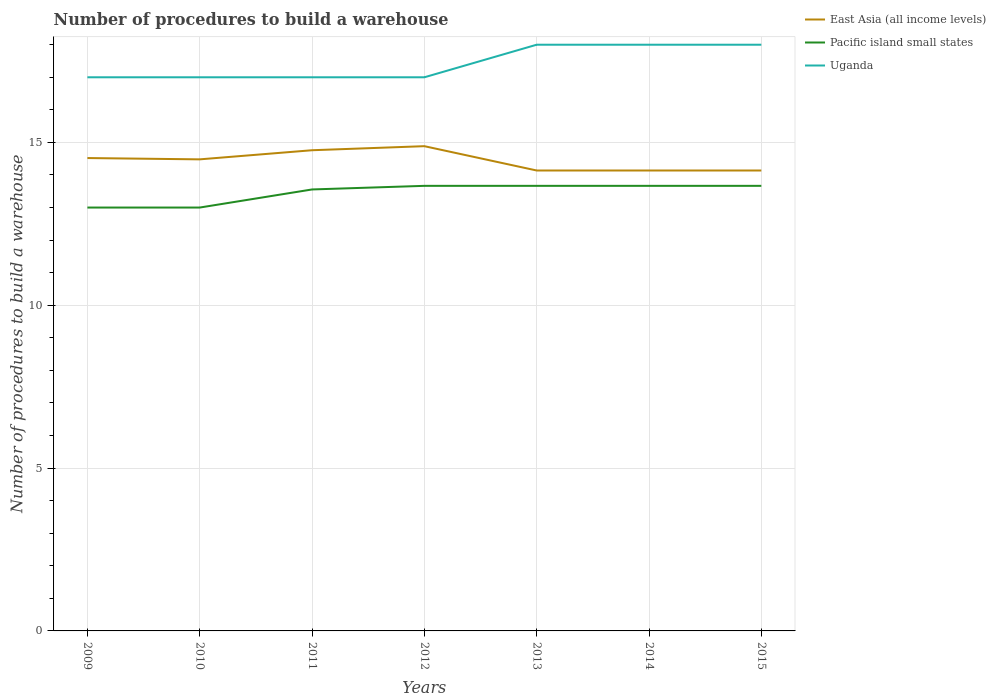How many different coloured lines are there?
Offer a very short reply. 3. Is the number of lines equal to the number of legend labels?
Offer a terse response. Yes. Across all years, what is the maximum number of procedures to build a warehouse in in East Asia (all income levels)?
Provide a short and direct response. 14.14. In which year was the number of procedures to build a warehouse in in Uganda maximum?
Keep it short and to the point. 2009. What is the total number of procedures to build a warehouse in in Pacific island small states in the graph?
Provide a short and direct response. 0. What is the difference between the highest and the second highest number of procedures to build a warehouse in in Uganda?
Provide a succinct answer. 1. How many lines are there?
Offer a very short reply. 3. How many years are there in the graph?
Make the answer very short. 7. What is the difference between two consecutive major ticks on the Y-axis?
Ensure brevity in your answer.  5. Does the graph contain any zero values?
Ensure brevity in your answer.  No. How many legend labels are there?
Give a very brief answer. 3. What is the title of the graph?
Offer a terse response. Number of procedures to build a warehouse. Does "Latin America(developing only)" appear as one of the legend labels in the graph?
Offer a terse response. No. What is the label or title of the X-axis?
Your response must be concise. Years. What is the label or title of the Y-axis?
Your answer should be very brief. Number of procedures to build a warehouse. What is the Number of procedures to build a warehouse in East Asia (all income levels) in 2009?
Your answer should be very brief. 14.52. What is the Number of procedures to build a warehouse of Pacific island small states in 2009?
Give a very brief answer. 13. What is the Number of procedures to build a warehouse of East Asia (all income levels) in 2010?
Give a very brief answer. 14.48. What is the Number of procedures to build a warehouse in East Asia (all income levels) in 2011?
Provide a short and direct response. 14.76. What is the Number of procedures to build a warehouse in Pacific island small states in 2011?
Keep it short and to the point. 13.56. What is the Number of procedures to build a warehouse of Uganda in 2011?
Your answer should be compact. 17. What is the Number of procedures to build a warehouse in East Asia (all income levels) in 2012?
Give a very brief answer. 14.88. What is the Number of procedures to build a warehouse of Pacific island small states in 2012?
Your response must be concise. 13.67. What is the Number of procedures to build a warehouse in Uganda in 2012?
Provide a succinct answer. 17. What is the Number of procedures to build a warehouse of East Asia (all income levels) in 2013?
Ensure brevity in your answer.  14.14. What is the Number of procedures to build a warehouse in Pacific island small states in 2013?
Keep it short and to the point. 13.67. What is the Number of procedures to build a warehouse of Uganda in 2013?
Provide a short and direct response. 18. What is the Number of procedures to build a warehouse in East Asia (all income levels) in 2014?
Your answer should be very brief. 14.14. What is the Number of procedures to build a warehouse in Pacific island small states in 2014?
Offer a terse response. 13.67. What is the Number of procedures to build a warehouse of East Asia (all income levels) in 2015?
Make the answer very short. 14.14. What is the Number of procedures to build a warehouse in Pacific island small states in 2015?
Provide a succinct answer. 13.67. What is the Number of procedures to build a warehouse of Uganda in 2015?
Offer a terse response. 18. Across all years, what is the maximum Number of procedures to build a warehouse of East Asia (all income levels)?
Your answer should be very brief. 14.88. Across all years, what is the maximum Number of procedures to build a warehouse of Pacific island small states?
Your answer should be very brief. 13.67. Across all years, what is the maximum Number of procedures to build a warehouse in Uganda?
Your response must be concise. 18. Across all years, what is the minimum Number of procedures to build a warehouse in East Asia (all income levels)?
Keep it short and to the point. 14.14. What is the total Number of procedures to build a warehouse of East Asia (all income levels) in the graph?
Ensure brevity in your answer.  101.06. What is the total Number of procedures to build a warehouse of Pacific island small states in the graph?
Offer a very short reply. 94.22. What is the total Number of procedures to build a warehouse of Uganda in the graph?
Offer a very short reply. 122. What is the difference between the Number of procedures to build a warehouse of East Asia (all income levels) in 2009 and that in 2010?
Ensure brevity in your answer.  0.04. What is the difference between the Number of procedures to build a warehouse in Pacific island small states in 2009 and that in 2010?
Offer a terse response. 0. What is the difference between the Number of procedures to build a warehouse in East Asia (all income levels) in 2009 and that in 2011?
Ensure brevity in your answer.  -0.24. What is the difference between the Number of procedures to build a warehouse in Pacific island small states in 2009 and that in 2011?
Your answer should be compact. -0.56. What is the difference between the Number of procedures to build a warehouse in East Asia (all income levels) in 2009 and that in 2012?
Give a very brief answer. -0.36. What is the difference between the Number of procedures to build a warehouse of Pacific island small states in 2009 and that in 2012?
Give a very brief answer. -0.67. What is the difference between the Number of procedures to build a warehouse of Uganda in 2009 and that in 2012?
Offer a terse response. 0. What is the difference between the Number of procedures to build a warehouse of East Asia (all income levels) in 2009 and that in 2013?
Offer a very short reply. 0.38. What is the difference between the Number of procedures to build a warehouse in Uganda in 2009 and that in 2013?
Ensure brevity in your answer.  -1. What is the difference between the Number of procedures to build a warehouse of East Asia (all income levels) in 2009 and that in 2014?
Ensure brevity in your answer.  0.38. What is the difference between the Number of procedures to build a warehouse in Pacific island small states in 2009 and that in 2014?
Keep it short and to the point. -0.67. What is the difference between the Number of procedures to build a warehouse in Uganda in 2009 and that in 2014?
Provide a succinct answer. -1. What is the difference between the Number of procedures to build a warehouse of East Asia (all income levels) in 2009 and that in 2015?
Make the answer very short. 0.38. What is the difference between the Number of procedures to build a warehouse of Pacific island small states in 2009 and that in 2015?
Provide a succinct answer. -0.67. What is the difference between the Number of procedures to build a warehouse of East Asia (all income levels) in 2010 and that in 2011?
Your answer should be compact. -0.28. What is the difference between the Number of procedures to build a warehouse in Pacific island small states in 2010 and that in 2011?
Your answer should be compact. -0.56. What is the difference between the Number of procedures to build a warehouse in Uganda in 2010 and that in 2011?
Make the answer very short. 0. What is the difference between the Number of procedures to build a warehouse of East Asia (all income levels) in 2010 and that in 2012?
Your response must be concise. -0.4. What is the difference between the Number of procedures to build a warehouse in Uganda in 2010 and that in 2012?
Make the answer very short. 0. What is the difference between the Number of procedures to build a warehouse of East Asia (all income levels) in 2010 and that in 2013?
Ensure brevity in your answer.  0.34. What is the difference between the Number of procedures to build a warehouse of Pacific island small states in 2010 and that in 2013?
Ensure brevity in your answer.  -0.67. What is the difference between the Number of procedures to build a warehouse of Uganda in 2010 and that in 2013?
Keep it short and to the point. -1. What is the difference between the Number of procedures to build a warehouse in East Asia (all income levels) in 2010 and that in 2014?
Ensure brevity in your answer.  0.34. What is the difference between the Number of procedures to build a warehouse of Pacific island small states in 2010 and that in 2014?
Give a very brief answer. -0.67. What is the difference between the Number of procedures to build a warehouse in Uganda in 2010 and that in 2014?
Ensure brevity in your answer.  -1. What is the difference between the Number of procedures to build a warehouse of East Asia (all income levels) in 2010 and that in 2015?
Your answer should be very brief. 0.34. What is the difference between the Number of procedures to build a warehouse in Uganda in 2010 and that in 2015?
Your answer should be very brief. -1. What is the difference between the Number of procedures to build a warehouse of East Asia (all income levels) in 2011 and that in 2012?
Offer a terse response. -0.12. What is the difference between the Number of procedures to build a warehouse of Pacific island small states in 2011 and that in 2012?
Offer a very short reply. -0.11. What is the difference between the Number of procedures to build a warehouse in Uganda in 2011 and that in 2012?
Make the answer very short. 0. What is the difference between the Number of procedures to build a warehouse of East Asia (all income levels) in 2011 and that in 2013?
Make the answer very short. 0.62. What is the difference between the Number of procedures to build a warehouse of Pacific island small states in 2011 and that in 2013?
Provide a short and direct response. -0.11. What is the difference between the Number of procedures to build a warehouse of East Asia (all income levels) in 2011 and that in 2014?
Your response must be concise. 0.62. What is the difference between the Number of procedures to build a warehouse of Pacific island small states in 2011 and that in 2014?
Your response must be concise. -0.11. What is the difference between the Number of procedures to build a warehouse in East Asia (all income levels) in 2011 and that in 2015?
Keep it short and to the point. 0.62. What is the difference between the Number of procedures to build a warehouse of Pacific island small states in 2011 and that in 2015?
Provide a short and direct response. -0.11. What is the difference between the Number of procedures to build a warehouse of East Asia (all income levels) in 2012 and that in 2013?
Your response must be concise. 0.75. What is the difference between the Number of procedures to build a warehouse of Pacific island small states in 2012 and that in 2013?
Ensure brevity in your answer.  0. What is the difference between the Number of procedures to build a warehouse in Uganda in 2012 and that in 2013?
Keep it short and to the point. -1. What is the difference between the Number of procedures to build a warehouse in East Asia (all income levels) in 2012 and that in 2014?
Offer a terse response. 0.75. What is the difference between the Number of procedures to build a warehouse in Uganda in 2012 and that in 2014?
Ensure brevity in your answer.  -1. What is the difference between the Number of procedures to build a warehouse in East Asia (all income levels) in 2012 and that in 2015?
Your answer should be very brief. 0.75. What is the difference between the Number of procedures to build a warehouse of Uganda in 2012 and that in 2015?
Give a very brief answer. -1. What is the difference between the Number of procedures to build a warehouse in East Asia (all income levels) in 2013 and that in 2015?
Your answer should be very brief. 0. What is the difference between the Number of procedures to build a warehouse in Uganda in 2013 and that in 2015?
Keep it short and to the point. 0. What is the difference between the Number of procedures to build a warehouse of Pacific island small states in 2014 and that in 2015?
Give a very brief answer. 0. What is the difference between the Number of procedures to build a warehouse in Uganda in 2014 and that in 2015?
Provide a succinct answer. 0. What is the difference between the Number of procedures to build a warehouse of East Asia (all income levels) in 2009 and the Number of procedures to build a warehouse of Pacific island small states in 2010?
Your answer should be compact. 1.52. What is the difference between the Number of procedures to build a warehouse in East Asia (all income levels) in 2009 and the Number of procedures to build a warehouse in Uganda in 2010?
Your answer should be very brief. -2.48. What is the difference between the Number of procedures to build a warehouse of East Asia (all income levels) in 2009 and the Number of procedures to build a warehouse of Pacific island small states in 2011?
Offer a terse response. 0.96. What is the difference between the Number of procedures to build a warehouse of East Asia (all income levels) in 2009 and the Number of procedures to build a warehouse of Uganda in 2011?
Keep it short and to the point. -2.48. What is the difference between the Number of procedures to build a warehouse in Pacific island small states in 2009 and the Number of procedures to build a warehouse in Uganda in 2011?
Keep it short and to the point. -4. What is the difference between the Number of procedures to build a warehouse of East Asia (all income levels) in 2009 and the Number of procedures to build a warehouse of Pacific island small states in 2012?
Provide a succinct answer. 0.85. What is the difference between the Number of procedures to build a warehouse in East Asia (all income levels) in 2009 and the Number of procedures to build a warehouse in Uganda in 2012?
Ensure brevity in your answer.  -2.48. What is the difference between the Number of procedures to build a warehouse of East Asia (all income levels) in 2009 and the Number of procedures to build a warehouse of Pacific island small states in 2013?
Provide a short and direct response. 0.85. What is the difference between the Number of procedures to build a warehouse of East Asia (all income levels) in 2009 and the Number of procedures to build a warehouse of Uganda in 2013?
Provide a succinct answer. -3.48. What is the difference between the Number of procedures to build a warehouse of Pacific island small states in 2009 and the Number of procedures to build a warehouse of Uganda in 2013?
Ensure brevity in your answer.  -5. What is the difference between the Number of procedures to build a warehouse in East Asia (all income levels) in 2009 and the Number of procedures to build a warehouse in Pacific island small states in 2014?
Give a very brief answer. 0.85. What is the difference between the Number of procedures to build a warehouse of East Asia (all income levels) in 2009 and the Number of procedures to build a warehouse of Uganda in 2014?
Your response must be concise. -3.48. What is the difference between the Number of procedures to build a warehouse of East Asia (all income levels) in 2009 and the Number of procedures to build a warehouse of Pacific island small states in 2015?
Give a very brief answer. 0.85. What is the difference between the Number of procedures to build a warehouse of East Asia (all income levels) in 2009 and the Number of procedures to build a warehouse of Uganda in 2015?
Provide a short and direct response. -3.48. What is the difference between the Number of procedures to build a warehouse in East Asia (all income levels) in 2010 and the Number of procedures to build a warehouse in Pacific island small states in 2011?
Your response must be concise. 0.92. What is the difference between the Number of procedures to build a warehouse of East Asia (all income levels) in 2010 and the Number of procedures to build a warehouse of Uganda in 2011?
Your answer should be very brief. -2.52. What is the difference between the Number of procedures to build a warehouse in Pacific island small states in 2010 and the Number of procedures to build a warehouse in Uganda in 2011?
Provide a short and direct response. -4. What is the difference between the Number of procedures to build a warehouse in East Asia (all income levels) in 2010 and the Number of procedures to build a warehouse in Pacific island small states in 2012?
Your answer should be very brief. 0.81. What is the difference between the Number of procedures to build a warehouse in East Asia (all income levels) in 2010 and the Number of procedures to build a warehouse in Uganda in 2012?
Ensure brevity in your answer.  -2.52. What is the difference between the Number of procedures to build a warehouse in Pacific island small states in 2010 and the Number of procedures to build a warehouse in Uganda in 2012?
Keep it short and to the point. -4. What is the difference between the Number of procedures to build a warehouse in East Asia (all income levels) in 2010 and the Number of procedures to build a warehouse in Pacific island small states in 2013?
Offer a terse response. 0.81. What is the difference between the Number of procedures to build a warehouse in East Asia (all income levels) in 2010 and the Number of procedures to build a warehouse in Uganda in 2013?
Your answer should be very brief. -3.52. What is the difference between the Number of procedures to build a warehouse of Pacific island small states in 2010 and the Number of procedures to build a warehouse of Uganda in 2013?
Your response must be concise. -5. What is the difference between the Number of procedures to build a warehouse of East Asia (all income levels) in 2010 and the Number of procedures to build a warehouse of Pacific island small states in 2014?
Offer a terse response. 0.81. What is the difference between the Number of procedures to build a warehouse of East Asia (all income levels) in 2010 and the Number of procedures to build a warehouse of Uganda in 2014?
Make the answer very short. -3.52. What is the difference between the Number of procedures to build a warehouse of Pacific island small states in 2010 and the Number of procedures to build a warehouse of Uganda in 2014?
Your response must be concise. -5. What is the difference between the Number of procedures to build a warehouse in East Asia (all income levels) in 2010 and the Number of procedures to build a warehouse in Pacific island small states in 2015?
Offer a terse response. 0.81. What is the difference between the Number of procedures to build a warehouse of East Asia (all income levels) in 2010 and the Number of procedures to build a warehouse of Uganda in 2015?
Make the answer very short. -3.52. What is the difference between the Number of procedures to build a warehouse in East Asia (all income levels) in 2011 and the Number of procedures to build a warehouse in Pacific island small states in 2012?
Your answer should be compact. 1.09. What is the difference between the Number of procedures to build a warehouse in East Asia (all income levels) in 2011 and the Number of procedures to build a warehouse in Uganda in 2012?
Ensure brevity in your answer.  -2.24. What is the difference between the Number of procedures to build a warehouse of Pacific island small states in 2011 and the Number of procedures to build a warehouse of Uganda in 2012?
Your answer should be compact. -3.44. What is the difference between the Number of procedures to build a warehouse of East Asia (all income levels) in 2011 and the Number of procedures to build a warehouse of Pacific island small states in 2013?
Provide a succinct answer. 1.09. What is the difference between the Number of procedures to build a warehouse of East Asia (all income levels) in 2011 and the Number of procedures to build a warehouse of Uganda in 2013?
Provide a succinct answer. -3.24. What is the difference between the Number of procedures to build a warehouse in Pacific island small states in 2011 and the Number of procedures to build a warehouse in Uganda in 2013?
Offer a terse response. -4.44. What is the difference between the Number of procedures to build a warehouse of East Asia (all income levels) in 2011 and the Number of procedures to build a warehouse of Pacific island small states in 2014?
Your answer should be very brief. 1.09. What is the difference between the Number of procedures to build a warehouse in East Asia (all income levels) in 2011 and the Number of procedures to build a warehouse in Uganda in 2014?
Provide a short and direct response. -3.24. What is the difference between the Number of procedures to build a warehouse of Pacific island small states in 2011 and the Number of procedures to build a warehouse of Uganda in 2014?
Keep it short and to the point. -4.44. What is the difference between the Number of procedures to build a warehouse of East Asia (all income levels) in 2011 and the Number of procedures to build a warehouse of Pacific island small states in 2015?
Your answer should be compact. 1.09. What is the difference between the Number of procedures to build a warehouse in East Asia (all income levels) in 2011 and the Number of procedures to build a warehouse in Uganda in 2015?
Keep it short and to the point. -3.24. What is the difference between the Number of procedures to build a warehouse of Pacific island small states in 2011 and the Number of procedures to build a warehouse of Uganda in 2015?
Ensure brevity in your answer.  -4.44. What is the difference between the Number of procedures to build a warehouse in East Asia (all income levels) in 2012 and the Number of procedures to build a warehouse in Pacific island small states in 2013?
Give a very brief answer. 1.22. What is the difference between the Number of procedures to build a warehouse of East Asia (all income levels) in 2012 and the Number of procedures to build a warehouse of Uganda in 2013?
Make the answer very short. -3.12. What is the difference between the Number of procedures to build a warehouse in Pacific island small states in 2012 and the Number of procedures to build a warehouse in Uganda in 2013?
Provide a short and direct response. -4.33. What is the difference between the Number of procedures to build a warehouse of East Asia (all income levels) in 2012 and the Number of procedures to build a warehouse of Pacific island small states in 2014?
Your response must be concise. 1.22. What is the difference between the Number of procedures to build a warehouse in East Asia (all income levels) in 2012 and the Number of procedures to build a warehouse in Uganda in 2014?
Make the answer very short. -3.12. What is the difference between the Number of procedures to build a warehouse in Pacific island small states in 2012 and the Number of procedures to build a warehouse in Uganda in 2014?
Ensure brevity in your answer.  -4.33. What is the difference between the Number of procedures to build a warehouse in East Asia (all income levels) in 2012 and the Number of procedures to build a warehouse in Pacific island small states in 2015?
Offer a terse response. 1.22. What is the difference between the Number of procedures to build a warehouse in East Asia (all income levels) in 2012 and the Number of procedures to build a warehouse in Uganda in 2015?
Provide a succinct answer. -3.12. What is the difference between the Number of procedures to build a warehouse in Pacific island small states in 2012 and the Number of procedures to build a warehouse in Uganda in 2015?
Keep it short and to the point. -4.33. What is the difference between the Number of procedures to build a warehouse in East Asia (all income levels) in 2013 and the Number of procedures to build a warehouse in Pacific island small states in 2014?
Give a very brief answer. 0.47. What is the difference between the Number of procedures to build a warehouse in East Asia (all income levels) in 2013 and the Number of procedures to build a warehouse in Uganda in 2014?
Your answer should be compact. -3.86. What is the difference between the Number of procedures to build a warehouse in Pacific island small states in 2013 and the Number of procedures to build a warehouse in Uganda in 2014?
Provide a short and direct response. -4.33. What is the difference between the Number of procedures to build a warehouse of East Asia (all income levels) in 2013 and the Number of procedures to build a warehouse of Pacific island small states in 2015?
Provide a succinct answer. 0.47. What is the difference between the Number of procedures to build a warehouse of East Asia (all income levels) in 2013 and the Number of procedures to build a warehouse of Uganda in 2015?
Ensure brevity in your answer.  -3.86. What is the difference between the Number of procedures to build a warehouse of Pacific island small states in 2013 and the Number of procedures to build a warehouse of Uganda in 2015?
Ensure brevity in your answer.  -4.33. What is the difference between the Number of procedures to build a warehouse of East Asia (all income levels) in 2014 and the Number of procedures to build a warehouse of Pacific island small states in 2015?
Offer a terse response. 0.47. What is the difference between the Number of procedures to build a warehouse of East Asia (all income levels) in 2014 and the Number of procedures to build a warehouse of Uganda in 2015?
Give a very brief answer. -3.86. What is the difference between the Number of procedures to build a warehouse in Pacific island small states in 2014 and the Number of procedures to build a warehouse in Uganda in 2015?
Your response must be concise. -4.33. What is the average Number of procedures to build a warehouse of East Asia (all income levels) per year?
Give a very brief answer. 14.44. What is the average Number of procedures to build a warehouse of Pacific island small states per year?
Make the answer very short. 13.46. What is the average Number of procedures to build a warehouse of Uganda per year?
Keep it short and to the point. 17.43. In the year 2009, what is the difference between the Number of procedures to build a warehouse in East Asia (all income levels) and Number of procedures to build a warehouse in Pacific island small states?
Give a very brief answer. 1.52. In the year 2009, what is the difference between the Number of procedures to build a warehouse in East Asia (all income levels) and Number of procedures to build a warehouse in Uganda?
Provide a short and direct response. -2.48. In the year 2009, what is the difference between the Number of procedures to build a warehouse of Pacific island small states and Number of procedures to build a warehouse of Uganda?
Your response must be concise. -4. In the year 2010, what is the difference between the Number of procedures to build a warehouse of East Asia (all income levels) and Number of procedures to build a warehouse of Pacific island small states?
Give a very brief answer. 1.48. In the year 2010, what is the difference between the Number of procedures to build a warehouse in East Asia (all income levels) and Number of procedures to build a warehouse in Uganda?
Ensure brevity in your answer.  -2.52. In the year 2011, what is the difference between the Number of procedures to build a warehouse of East Asia (all income levels) and Number of procedures to build a warehouse of Pacific island small states?
Your answer should be compact. 1.2. In the year 2011, what is the difference between the Number of procedures to build a warehouse in East Asia (all income levels) and Number of procedures to build a warehouse in Uganda?
Your response must be concise. -2.24. In the year 2011, what is the difference between the Number of procedures to build a warehouse in Pacific island small states and Number of procedures to build a warehouse in Uganda?
Provide a succinct answer. -3.44. In the year 2012, what is the difference between the Number of procedures to build a warehouse of East Asia (all income levels) and Number of procedures to build a warehouse of Pacific island small states?
Keep it short and to the point. 1.22. In the year 2012, what is the difference between the Number of procedures to build a warehouse in East Asia (all income levels) and Number of procedures to build a warehouse in Uganda?
Offer a very short reply. -2.12. In the year 2013, what is the difference between the Number of procedures to build a warehouse in East Asia (all income levels) and Number of procedures to build a warehouse in Pacific island small states?
Provide a succinct answer. 0.47. In the year 2013, what is the difference between the Number of procedures to build a warehouse of East Asia (all income levels) and Number of procedures to build a warehouse of Uganda?
Your answer should be compact. -3.86. In the year 2013, what is the difference between the Number of procedures to build a warehouse in Pacific island small states and Number of procedures to build a warehouse in Uganda?
Your answer should be very brief. -4.33. In the year 2014, what is the difference between the Number of procedures to build a warehouse of East Asia (all income levels) and Number of procedures to build a warehouse of Pacific island small states?
Keep it short and to the point. 0.47. In the year 2014, what is the difference between the Number of procedures to build a warehouse in East Asia (all income levels) and Number of procedures to build a warehouse in Uganda?
Make the answer very short. -3.86. In the year 2014, what is the difference between the Number of procedures to build a warehouse of Pacific island small states and Number of procedures to build a warehouse of Uganda?
Make the answer very short. -4.33. In the year 2015, what is the difference between the Number of procedures to build a warehouse of East Asia (all income levels) and Number of procedures to build a warehouse of Pacific island small states?
Provide a succinct answer. 0.47. In the year 2015, what is the difference between the Number of procedures to build a warehouse in East Asia (all income levels) and Number of procedures to build a warehouse in Uganda?
Your response must be concise. -3.86. In the year 2015, what is the difference between the Number of procedures to build a warehouse of Pacific island small states and Number of procedures to build a warehouse of Uganda?
Ensure brevity in your answer.  -4.33. What is the ratio of the Number of procedures to build a warehouse of East Asia (all income levels) in 2009 to that in 2010?
Keep it short and to the point. 1. What is the ratio of the Number of procedures to build a warehouse of Pacific island small states in 2009 to that in 2010?
Offer a very short reply. 1. What is the ratio of the Number of procedures to build a warehouse in East Asia (all income levels) in 2009 to that in 2011?
Offer a terse response. 0.98. What is the ratio of the Number of procedures to build a warehouse in Pacific island small states in 2009 to that in 2011?
Ensure brevity in your answer.  0.96. What is the ratio of the Number of procedures to build a warehouse in East Asia (all income levels) in 2009 to that in 2012?
Your answer should be compact. 0.98. What is the ratio of the Number of procedures to build a warehouse in Pacific island small states in 2009 to that in 2012?
Your response must be concise. 0.95. What is the ratio of the Number of procedures to build a warehouse in Uganda in 2009 to that in 2012?
Ensure brevity in your answer.  1. What is the ratio of the Number of procedures to build a warehouse in Pacific island small states in 2009 to that in 2013?
Provide a succinct answer. 0.95. What is the ratio of the Number of procedures to build a warehouse in Pacific island small states in 2009 to that in 2014?
Offer a terse response. 0.95. What is the ratio of the Number of procedures to build a warehouse of East Asia (all income levels) in 2009 to that in 2015?
Give a very brief answer. 1.03. What is the ratio of the Number of procedures to build a warehouse of Pacific island small states in 2009 to that in 2015?
Provide a succinct answer. 0.95. What is the ratio of the Number of procedures to build a warehouse in Uganda in 2009 to that in 2015?
Give a very brief answer. 0.94. What is the ratio of the Number of procedures to build a warehouse of Pacific island small states in 2010 to that in 2011?
Keep it short and to the point. 0.96. What is the ratio of the Number of procedures to build a warehouse in East Asia (all income levels) in 2010 to that in 2012?
Offer a very short reply. 0.97. What is the ratio of the Number of procedures to build a warehouse in Pacific island small states in 2010 to that in 2012?
Offer a terse response. 0.95. What is the ratio of the Number of procedures to build a warehouse in Uganda in 2010 to that in 2012?
Offer a terse response. 1. What is the ratio of the Number of procedures to build a warehouse of East Asia (all income levels) in 2010 to that in 2013?
Provide a short and direct response. 1.02. What is the ratio of the Number of procedures to build a warehouse of Pacific island small states in 2010 to that in 2013?
Provide a succinct answer. 0.95. What is the ratio of the Number of procedures to build a warehouse of Uganda in 2010 to that in 2013?
Your response must be concise. 0.94. What is the ratio of the Number of procedures to build a warehouse in East Asia (all income levels) in 2010 to that in 2014?
Give a very brief answer. 1.02. What is the ratio of the Number of procedures to build a warehouse in Pacific island small states in 2010 to that in 2014?
Your answer should be very brief. 0.95. What is the ratio of the Number of procedures to build a warehouse in East Asia (all income levels) in 2010 to that in 2015?
Ensure brevity in your answer.  1.02. What is the ratio of the Number of procedures to build a warehouse in Pacific island small states in 2010 to that in 2015?
Your response must be concise. 0.95. What is the ratio of the Number of procedures to build a warehouse of Uganda in 2010 to that in 2015?
Provide a succinct answer. 0.94. What is the ratio of the Number of procedures to build a warehouse of East Asia (all income levels) in 2011 to that in 2012?
Offer a terse response. 0.99. What is the ratio of the Number of procedures to build a warehouse in Pacific island small states in 2011 to that in 2012?
Your response must be concise. 0.99. What is the ratio of the Number of procedures to build a warehouse of East Asia (all income levels) in 2011 to that in 2013?
Give a very brief answer. 1.04. What is the ratio of the Number of procedures to build a warehouse of Pacific island small states in 2011 to that in 2013?
Offer a terse response. 0.99. What is the ratio of the Number of procedures to build a warehouse of Uganda in 2011 to that in 2013?
Make the answer very short. 0.94. What is the ratio of the Number of procedures to build a warehouse of East Asia (all income levels) in 2011 to that in 2014?
Provide a short and direct response. 1.04. What is the ratio of the Number of procedures to build a warehouse of Uganda in 2011 to that in 2014?
Your response must be concise. 0.94. What is the ratio of the Number of procedures to build a warehouse of East Asia (all income levels) in 2011 to that in 2015?
Offer a very short reply. 1.04. What is the ratio of the Number of procedures to build a warehouse of Uganda in 2011 to that in 2015?
Ensure brevity in your answer.  0.94. What is the ratio of the Number of procedures to build a warehouse of East Asia (all income levels) in 2012 to that in 2013?
Your answer should be very brief. 1.05. What is the ratio of the Number of procedures to build a warehouse in East Asia (all income levels) in 2012 to that in 2014?
Your answer should be compact. 1.05. What is the ratio of the Number of procedures to build a warehouse in Uganda in 2012 to that in 2014?
Your response must be concise. 0.94. What is the ratio of the Number of procedures to build a warehouse of East Asia (all income levels) in 2012 to that in 2015?
Make the answer very short. 1.05. What is the ratio of the Number of procedures to build a warehouse of East Asia (all income levels) in 2013 to that in 2014?
Make the answer very short. 1. What is the ratio of the Number of procedures to build a warehouse in Pacific island small states in 2013 to that in 2014?
Provide a succinct answer. 1. What is the ratio of the Number of procedures to build a warehouse of East Asia (all income levels) in 2013 to that in 2015?
Ensure brevity in your answer.  1. What is the ratio of the Number of procedures to build a warehouse in East Asia (all income levels) in 2014 to that in 2015?
Give a very brief answer. 1. What is the ratio of the Number of procedures to build a warehouse in Uganda in 2014 to that in 2015?
Your response must be concise. 1. What is the difference between the highest and the second highest Number of procedures to build a warehouse of East Asia (all income levels)?
Ensure brevity in your answer.  0.12. What is the difference between the highest and the lowest Number of procedures to build a warehouse in East Asia (all income levels)?
Your answer should be very brief. 0.75. 